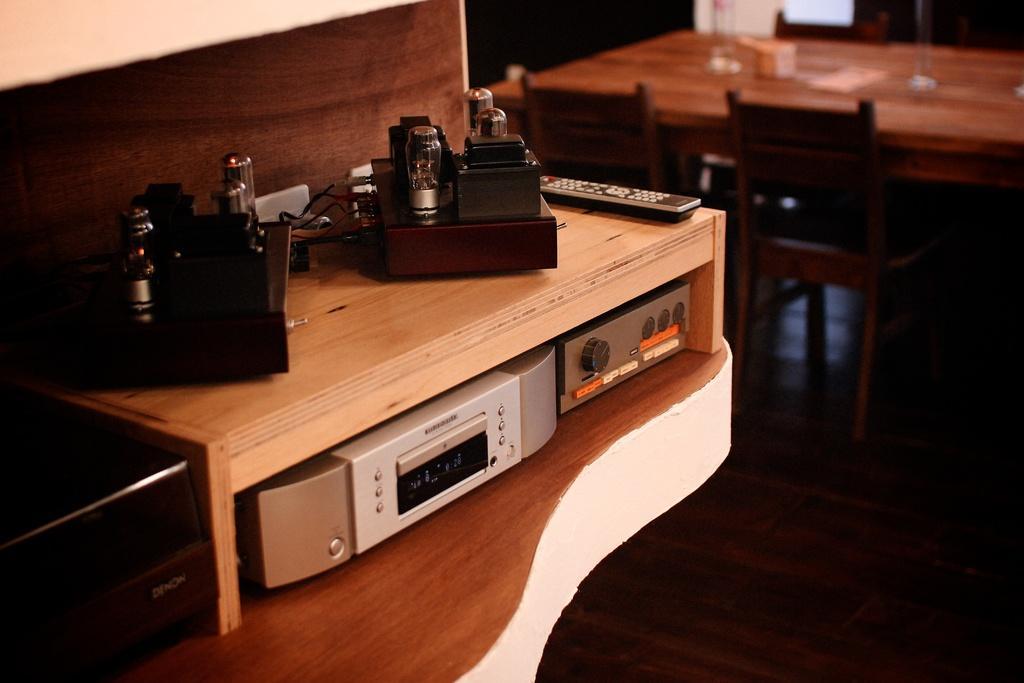Can you describe this image briefly? In the image there are many players,transistors and electronic equipment along with remote on a table, in the back there is a dining table with chairs on wooden floor. 